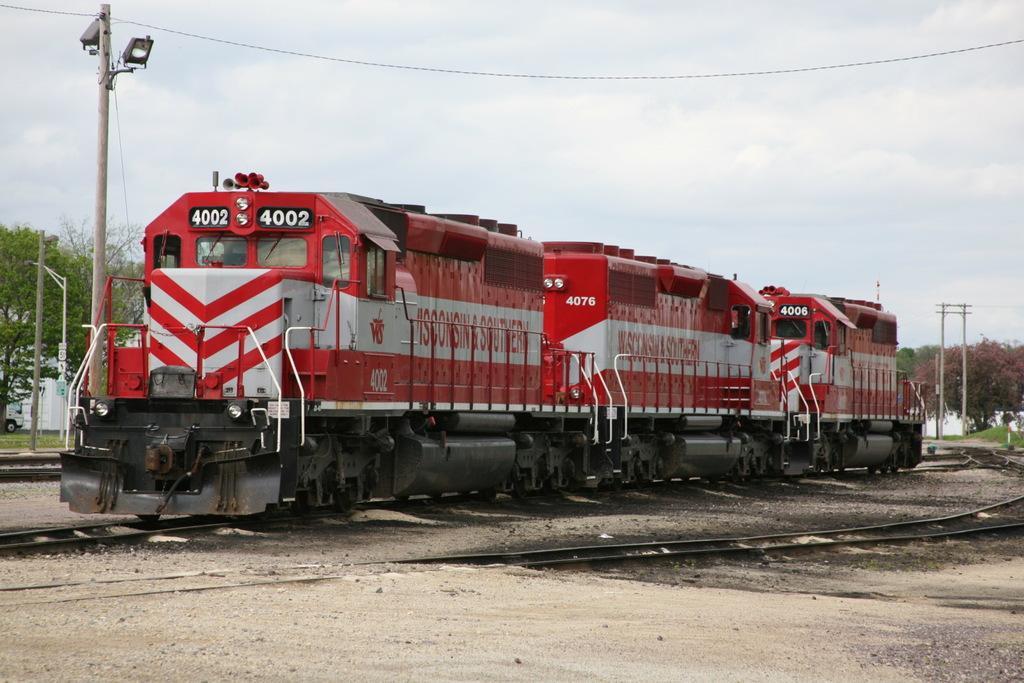Can you describe this image briefly? In this picture we can see a red train on the railway track surrounded by poles, trees and wires. 